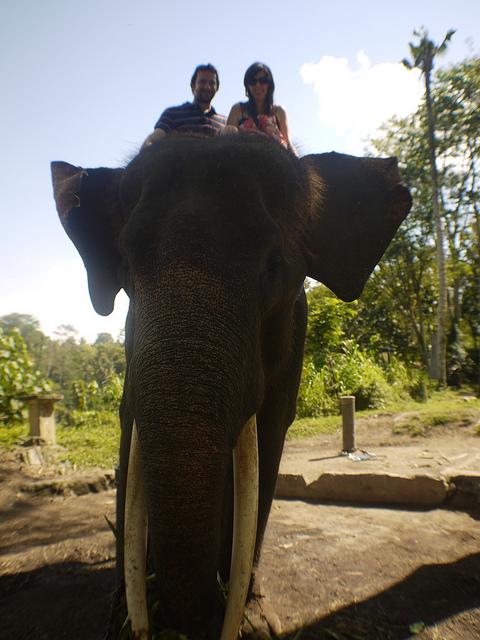Does this elephant seem healthy?
Give a very brief answer. Yes. Is the elephant eating a tree?
Concise answer only. No. Is this a wild elephant?
Short answer required. No. 